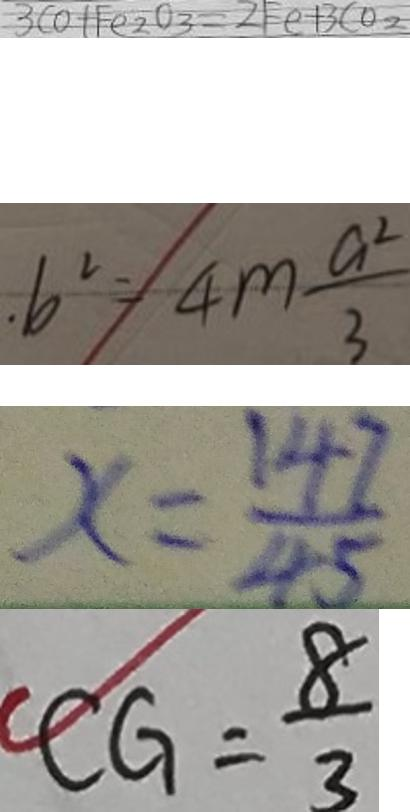<formula> <loc_0><loc_0><loc_500><loc_500>3 C O + F e _ { 2 } O _ { 3 } = 2 F e + 3 C o _ { 2 } 
 . b ^ { 2 } = 4 m \frac { a ^ { 2 } } { 3 } 
 x = \frac { 1 4 7 } { 4 5 } 
 C G = \frac { 8 } { 3 }</formula> 